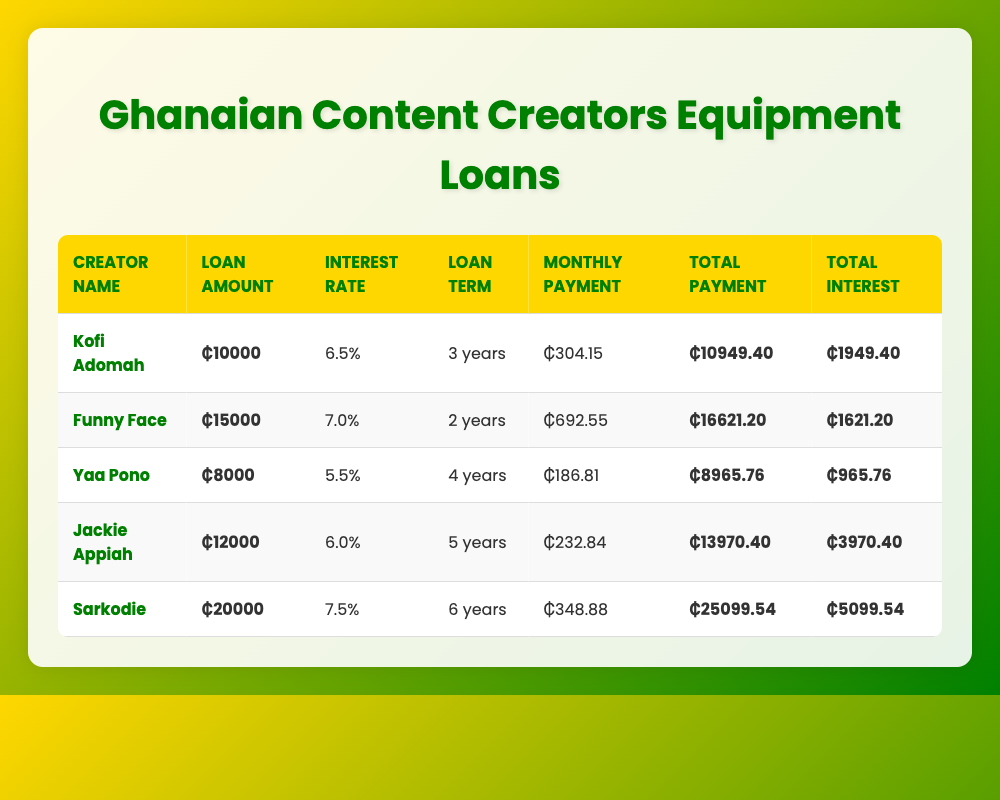What is the total loan amount taken by Sarkodie? Sarkodie's total loan amount is clearly listed in the table under the "Loan Amount" column next to his name. It shows ₵20000.
Answer: ₵20000 What is the monthly payment for Jackie Appiah's loan? Jackie Appiah's monthly payment can be found in the "Monthly Payment" column in her row, which indicates a payment of ₵232.84.
Answer: ₵232.84 Is the total interest paid by Funny Face greater than that paid by Kofi Adomah? To find the answer, we compare the "Total Interest" values: Funny Face paid ₵1621.20 and Kofi Adomah paid ₵1949.40. Since ₵1621.20 is less than ₵1949.40, the statement is false.
Answer: No What is the average total payment across all creators? To calculate the average, we sum the total payments: 10949.40 + 16621.20 + 8965.76 + 13970.40 + 25099.54 =  74696.30. Dividing that by the number of creators, which is 5, gives us the average total payment of 74696.30 / 5 = 14939.26.
Answer: ₵14939.26 Which creator has the highest total interest paid? Comparing the "Total Interest" amounts, we see Kofi Adomah with ₵1949.40, Funny Face with ₵1621.20, Yaa Pono with ₵965.76, Jackie Appiah with ₵3970.40, and Sarkodie with ₵5099.54. Sarkodie has the highest amount at ₵5099.54.
Answer: Sarkodie How many years is the longest loan term, and who has it? The longest loan term is highlighted in the "Loan Term" column. Sarkodie’s loan term is 6 years, which is the highest among all creators listed.
Answer: 6 years, Sarkodie What is the total payment difference between Yaa Pono and Jackie Appiah? We calculate the total payments: Yaa Pono's total payment is ₵8965.76 and Jackie Appiah's is ₵13970.40. The difference is ₵13970.40 - ₵8965.76 = ₵5004.64.
Answer: ₵5004.64 Is Kofi Adomah's loan term shorter than Jackie Appiah's? Kofi Adomah's loan term, from the "Loan Term" column, is 3 years, while Jackie Appiah's is 5 years. Since 3 years is less than 5 years, the answer is yes.
Answer: Yes What is the combined loan amount of Yaa Pono and Kofi Adomah? We add the loan amounts: Kofi Adomah's loan is ₵10000 and Yaa Pono's is ₵8000. The total is ₵10000 + ₵8000 = ₵18000.
Answer: ₵18000 